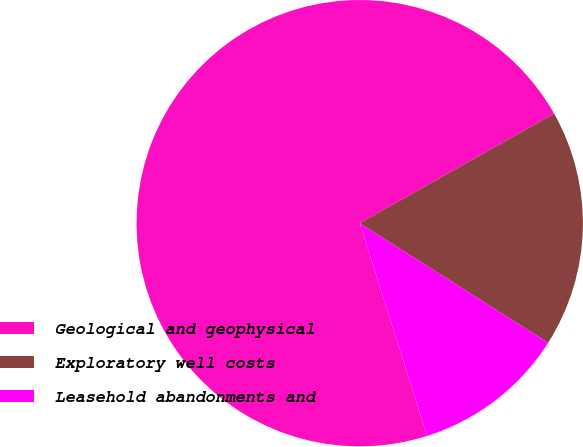<chart> <loc_0><loc_0><loc_500><loc_500><pie_chart><fcel>Geological and geophysical<fcel>Exploratory well costs<fcel>Leasehold abandonments and<nl><fcel>71.72%<fcel>17.17%<fcel>11.11%<nl></chart> 